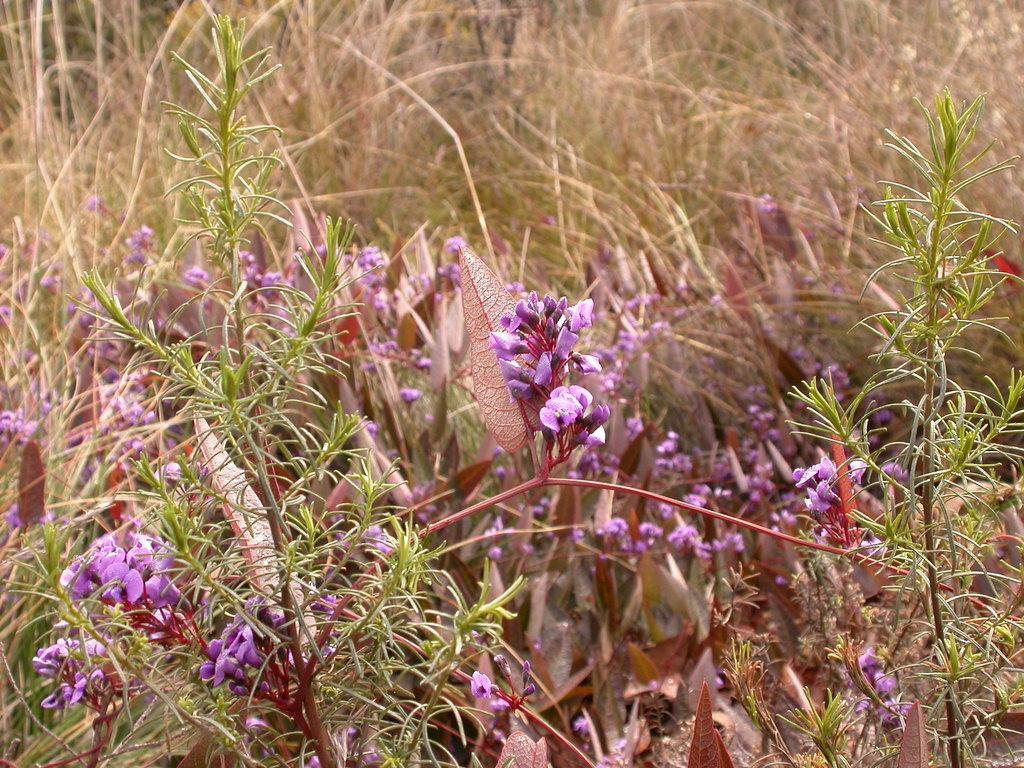What type of living organisms can be seen in the image? Plants and flowers are visible in the image. Can you describe the natural setting in the image? There is grass visible in the background of the image. What type of discussion is taking place in the image? There is no discussion present in the image; it features plants, flowers, and grass. Can you see any faces in the image? There are no faces visible in the image; it focuses on plants, flowers, and grass. 